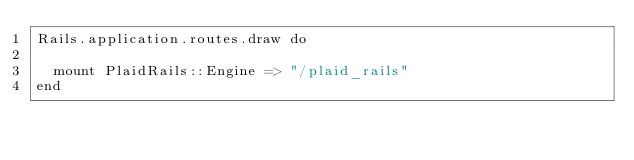<code> <loc_0><loc_0><loc_500><loc_500><_Ruby_>Rails.application.routes.draw do

  mount PlaidRails::Engine => "/plaid_rails"
end
</code> 